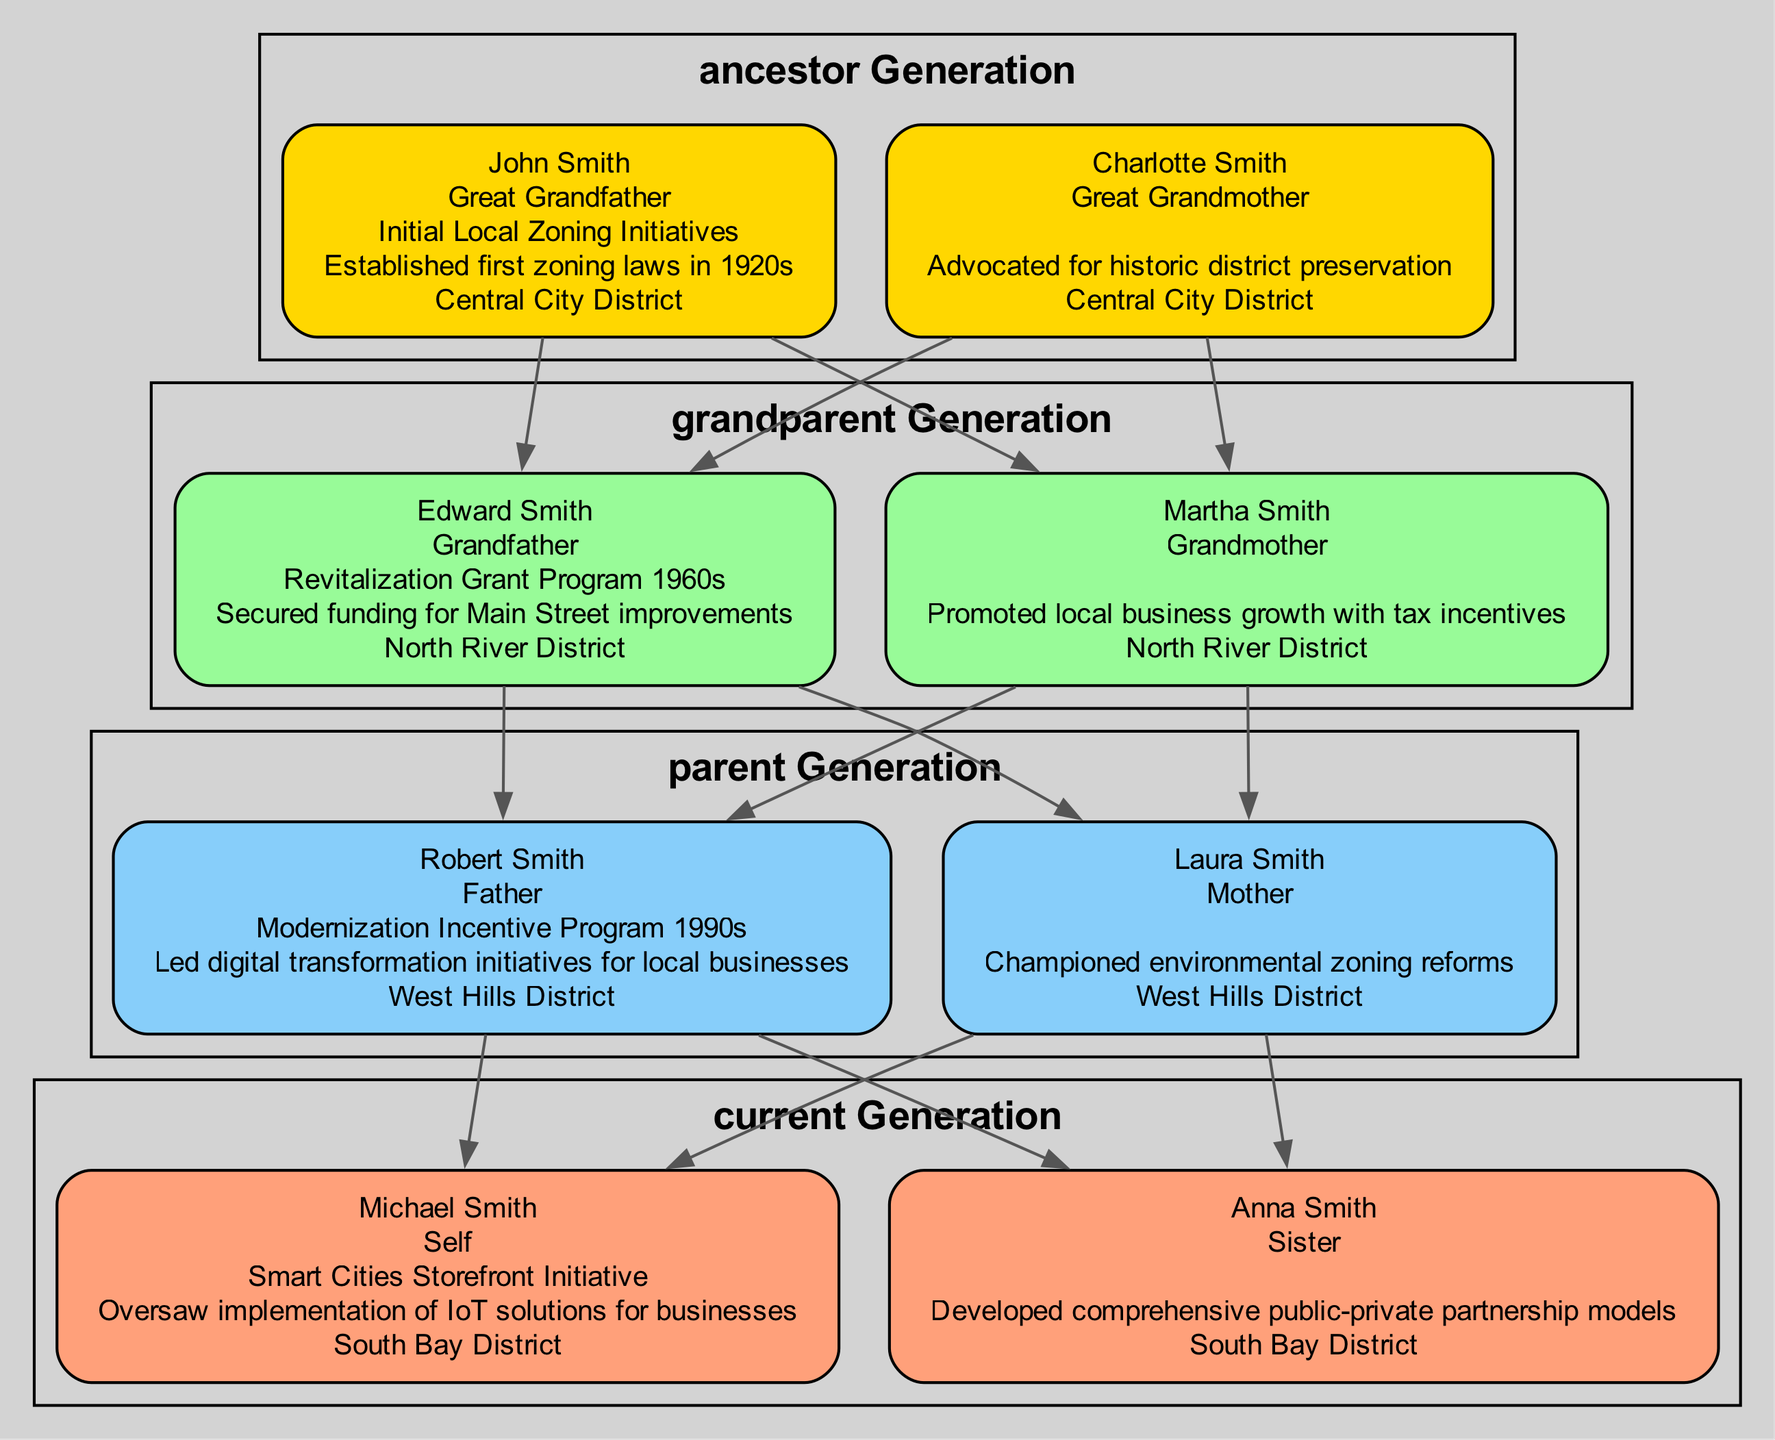What program did Robert Smith participate in? The diagram indicates that Robert Smith, the Father, was involved in the "Modernization Incentive Program 1990s" which is listed under his details.
Answer: Modernization Incentive Program 1990s How many generations are depicted in the diagram? The diagram showcases four generations: Ancestor Generation, Grandparent Generation, Parent Generation, and Current Generation. By counting each of these labels, we confirm that there are four distinct generations.
Answer: 4 Who is the Grandfather in the family tree? Referring to the diagram, "Edward Smith" is labeled as the Grandfather, which is directly stated under his node.
Answer: Edward Smith Which region did John Smith contribute to? The node for John Smith indicates that he contributed in the "Central City District," which is specified under his information in the diagram.
Answer: Central City District How many members are in the Current Generation? The diagram lists two members in the Current Generation: Michael Smith (Self) and Anna Smith (Sister), confirming the total count directly from the visual representation.
Answer: 2 What is the contribution of Charlotte Smith? According to the diagram, Charlotte Smith's contribution is noted as advocating for historic district preservation, which is explicitly listed in her details.
Answer: Advocated for historic district preservation What program did Michael Smith oversee? The diagram indicates that Michael Smith was involved in the "Smart Cities Storefront Initiative," which is clearly stated under his related information.
Answer: Smart Cities Storefront Initiative Who is the Sister in the family tree? The diagram specifies that Anna Smith is listed as the Sister, directly stated beneath her corresponding node in the Current Generation section.
Answer: Anna Smith What was the focus of Laura Smith's efforts? The diagram indicates that Laura Smith championed environmental zoning reforms, detailing her focus and contribution as shown in her node.
Answer: Championed environmental zoning reforms 